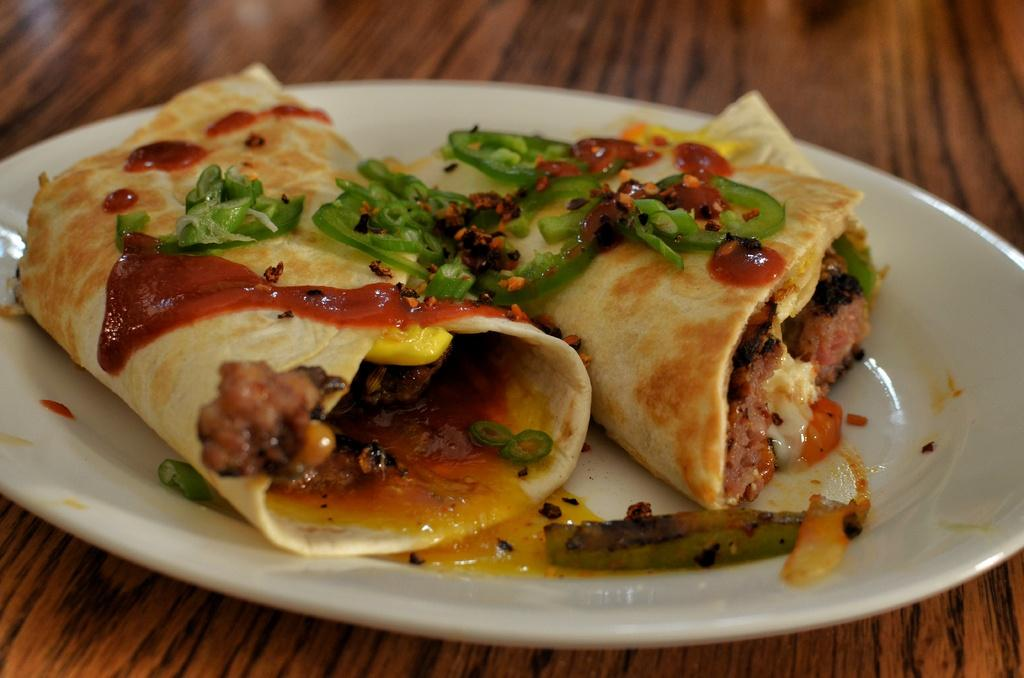What is the main subject of the image? There is a food item in the image. How is the food item presented in the image? The food item is placed on a plate. What type of substance is leaking from the stocking in the image? There is no stocking or substance present in the image; it only features a food item placed on a plate. 